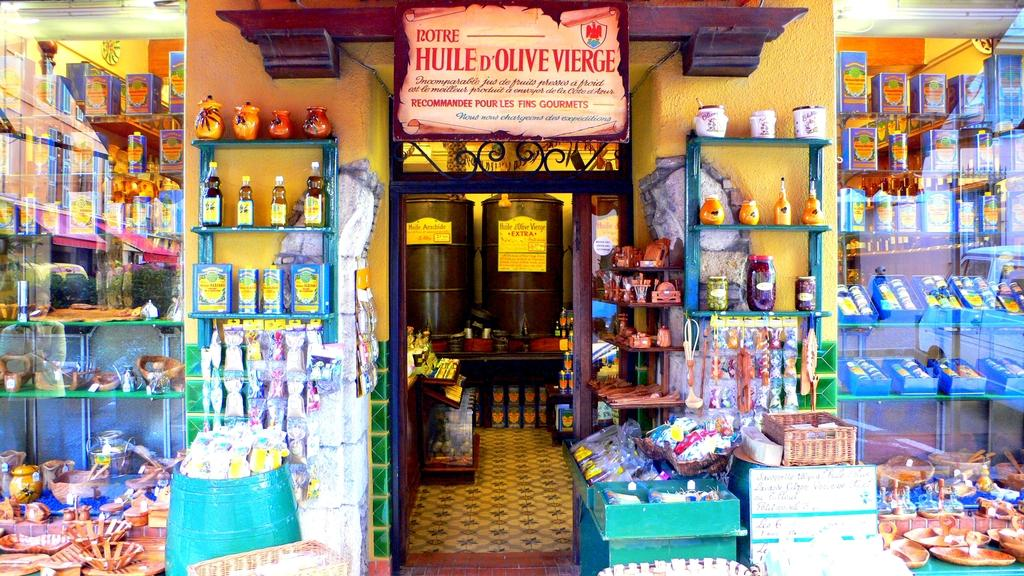Provide a one-sentence caption for the provided image. A crowded looking shop doorway with the word Rotre discernible on the top. 